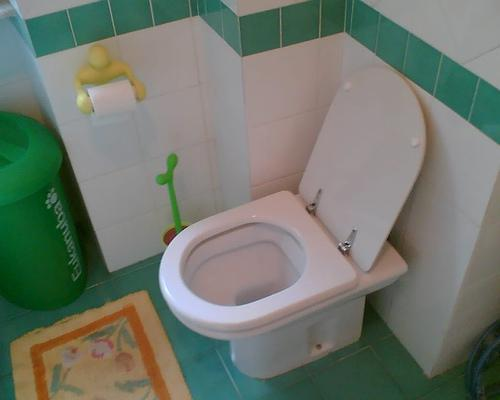Question: where was this photo taken?
Choices:
A. Bedroom.
B. Wine tasting.
C. At the wedding.
D. In a bathroom.
Answer with the letter. Answer: D Question: who is present?
Choices:
A. Three dancers.
B. Nobody.
C. A man on a horse.
D. A woman on a bike.
Answer with the letter. Answer: B Question: what is it for?
Choices:
A. To take a bath.
B. To wash your face.
C. To relieve yourself.
D. To see yourself.
Answer with the letter. Answer: C 